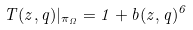<formula> <loc_0><loc_0><loc_500><loc_500>T ( z , q ) | _ { \pi _ { \Omega } } = 1 + b ( z , q ) ^ { 6 }</formula> 